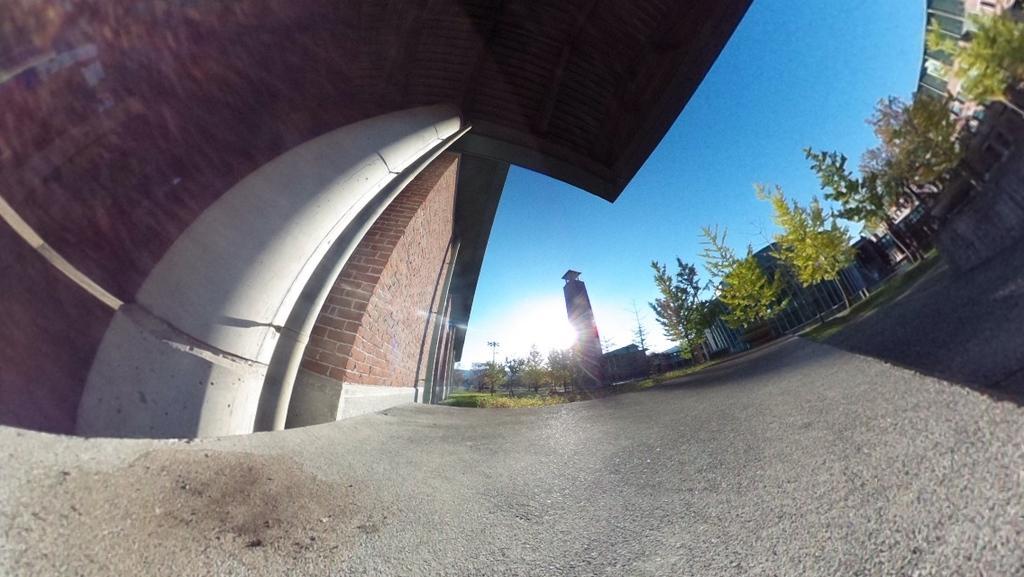In one or two sentences, can you explain what this image depicts? In this picture I can observe building in the middle of the picture. On the right side I can observe trees. In the background I can observe sky. 